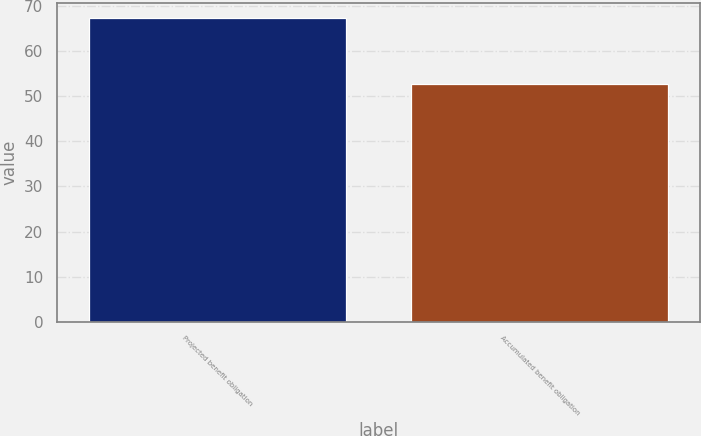Convert chart. <chart><loc_0><loc_0><loc_500><loc_500><bar_chart><fcel>Projected benefit obligation<fcel>Accumulated benefit obligation<nl><fcel>67.3<fcel>52.8<nl></chart> 